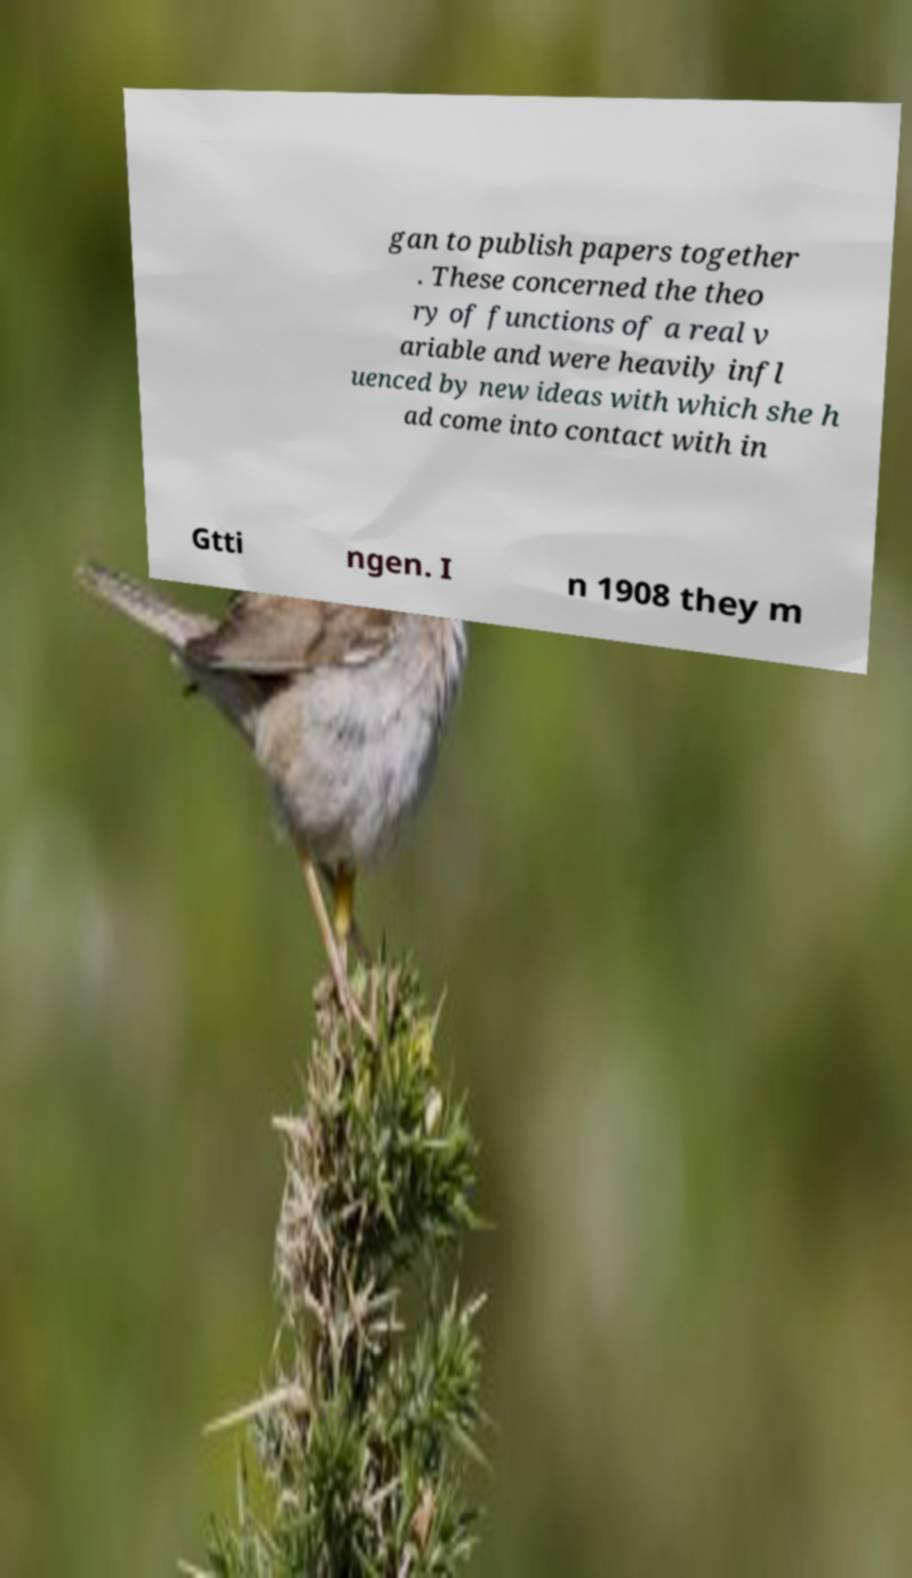I need the written content from this picture converted into text. Can you do that? gan to publish papers together . These concerned the theo ry of functions of a real v ariable and were heavily infl uenced by new ideas with which she h ad come into contact with in Gtti ngen. I n 1908 they m 